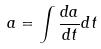Convert formula to latex. <formula><loc_0><loc_0><loc_500><loc_500>a = \int \frac { d a } { d t } d t</formula> 